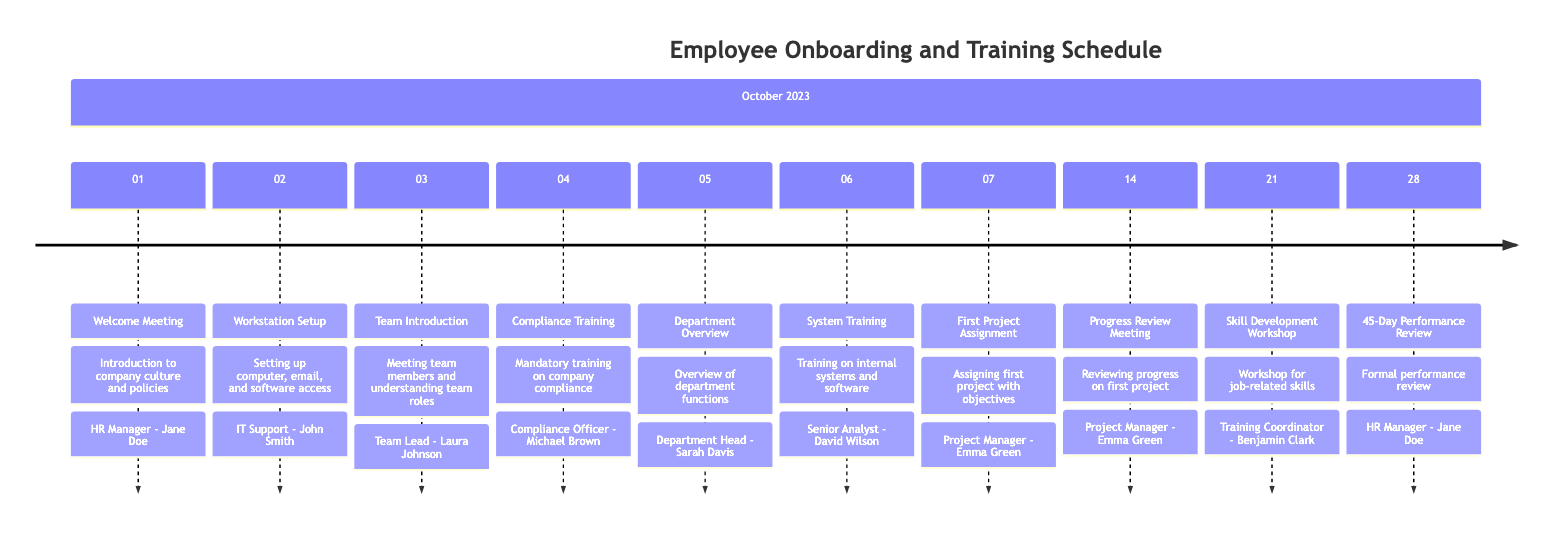What is the date of the Welcome Meeting? The Welcome Meeting is scheduled for October 1, 2023, as indicated directly in the timeline.
Answer: October 1, 2023 Who is responsible for the Compliance Training? The Compliance Training is led by the Compliance Officer, Michael Brown, who is specified in the details of that task on the timeline.
Answer: Compliance Officer - Michael Brown How many training sessions are there before the first project assignment? There are five training sessions listed (including the Welcome Meeting) before the first project assignment on October 7, 2023: Welcome Meeting, Workstation Setup, Team Introduction, Compliance Training, and Department Overview.
Answer: 5 What is the purpose of the Progress Review Meeting? The Progress Review Meeting on October 14, 2023, is designed to review the progress on the first project and provide feedback, as stated in the details of that task.
Answer: Reviewing progress on the first project and providing feedback Which day has the Skill Development Workshop scheduled? The Skill Development Workshop is scheduled for October 21, 2023, which is clearly indicated on the timeline.
Answer: October 21, 2023 Name the person responsible for the Department Overview. The Department Overview is handled by the Department Head, Sarah Davis, as noted in the task details on the timeline.
Answer: Department Head - Sarah Davis How many days after the first project assignment does the Progress Review occur? The Progress Review Meeting occurs 7 days after the first project assignment on October 14, 2023, which is 7 days after the project starts on October 7, 2023.
Answer: 7 days What is the final task listed in the timeline? The final task listed in the timeline is the 45-Day Performance Review, occurring on October 28, 2023, which is the last date noted.
Answer: 45-Day Performance Review 